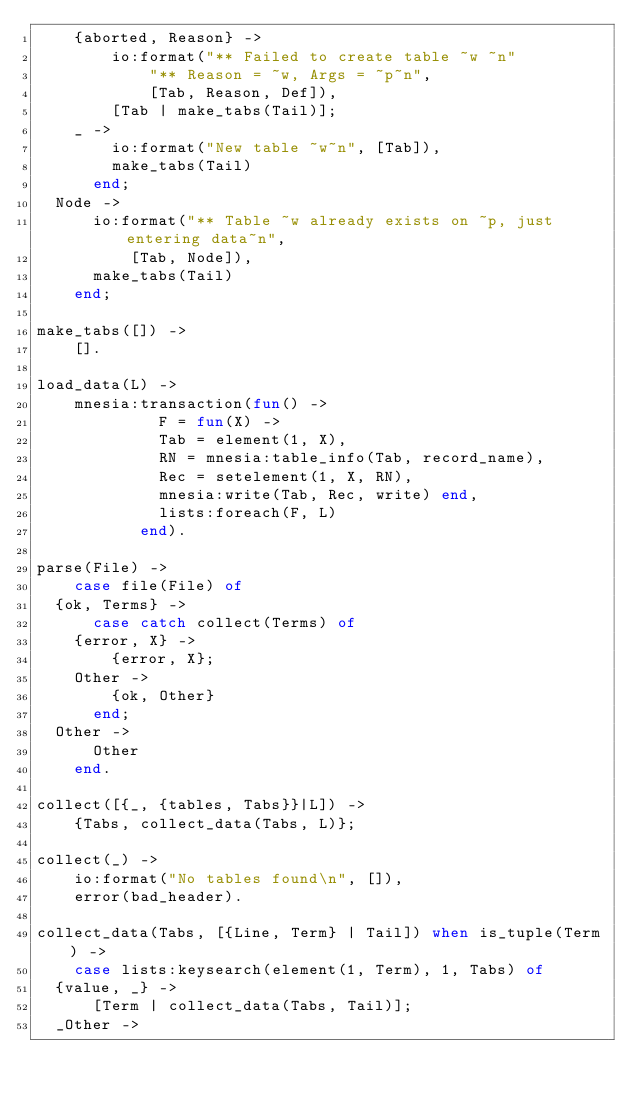Convert code to text. <code><loc_0><loc_0><loc_500><loc_500><_Erlang_>		{aborted, Reason} ->
		    io:format("** Failed to create table ~w ~n"
			      "** Reason = ~w, Args = ~p~n", 
			      [Tab, Reason, Def]),
		    [Tab | make_tabs(Tail)];
		_ -> 
		    io:format("New table ~w~n", [Tab]),
		    make_tabs(Tail)
	    end;
	Node ->
	    io:format("** Table ~w already exists on ~p, just entering data~n",
		      [Tab, Node]),
	    make_tabs(Tail)
    end;

make_tabs([]) -> 
    [].

load_data(L) ->
    mnesia:transaction(fun() ->
			       F = fun(X) -> 
					   Tab = element(1, X),
					   RN = mnesia:table_info(Tab, record_name),
					   Rec = setelement(1, X, RN),
					   mnesia:write(Tab, Rec, write) end,
			       lists:foreach(F, L)
		       end).

parse(File) ->
    case file(File) of
	{ok, Terms} ->
	    case catch collect(Terms) of
		{error, X} ->
		    {error, X};
		Other ->
		    {ok, Other}
	    end;
	Other ->
	    Other
    end.

collect([{_, {tables, Tabs}}|L]) ->
    {Tabs, collect_data(Tabs, L)};

collect(_) ->
    io:format("No tables found\n", []),
    error(bad_header).

collect_data(Tabs, [{Line, Term} | Tail]) when is_tuple(Term) ->
    case lists:keysearch(element(1, Term), 1, Tabs) of
	{value, _} ->
	    [Term | collect_data(Tabs, Tail)];
	_Other -></code> 